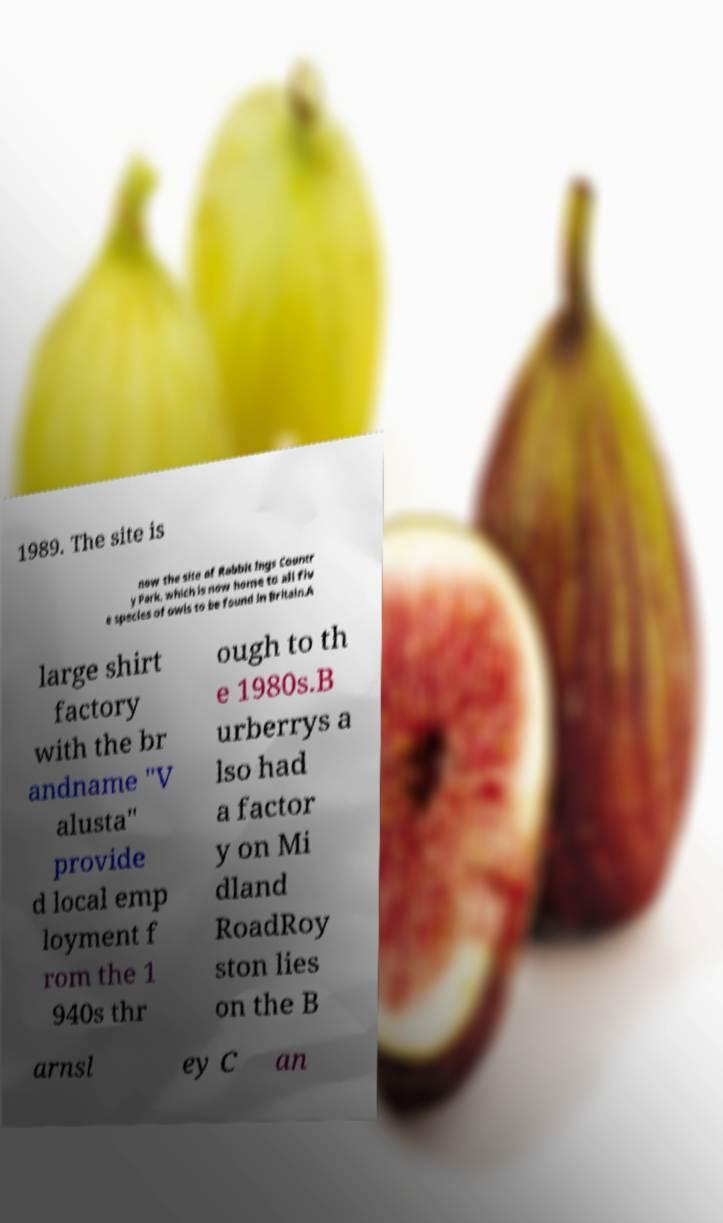Please read and relay the text visible in this image. What does it say? 1989. The site is now the site of Rabbit Ings Countr y Park, which is now home to all fiv e species of owls to be found in Britain.A large shirt factory with the br andname "V alusta" provide d local emp loyment f rom the 1 940s thr ough to th e 1980s.B urberrys a lso had a factor y on Mi dland RoadRoy ston lies on the B arnsl ey C an 